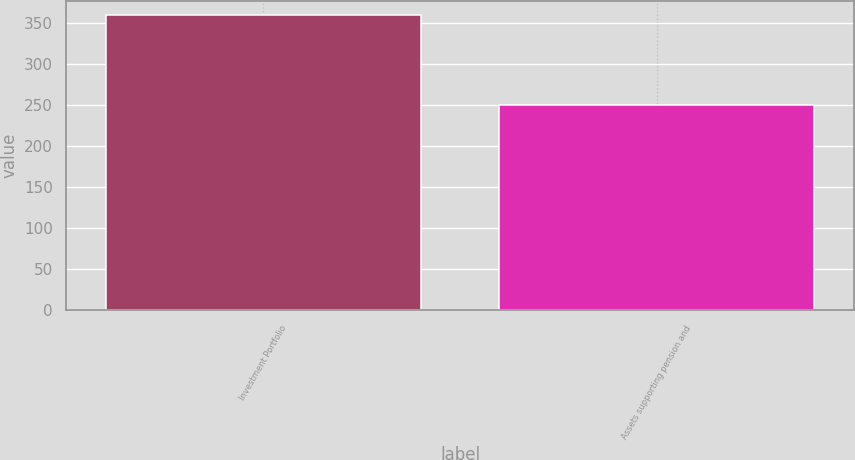<chart> <loc_0><loc_0><loc_500><loc_500><bar_chart><fcel>Investment Portfolio<fcel>Assets supporting pension and<nl><fcel>360<fcel>251<nl></chart> 